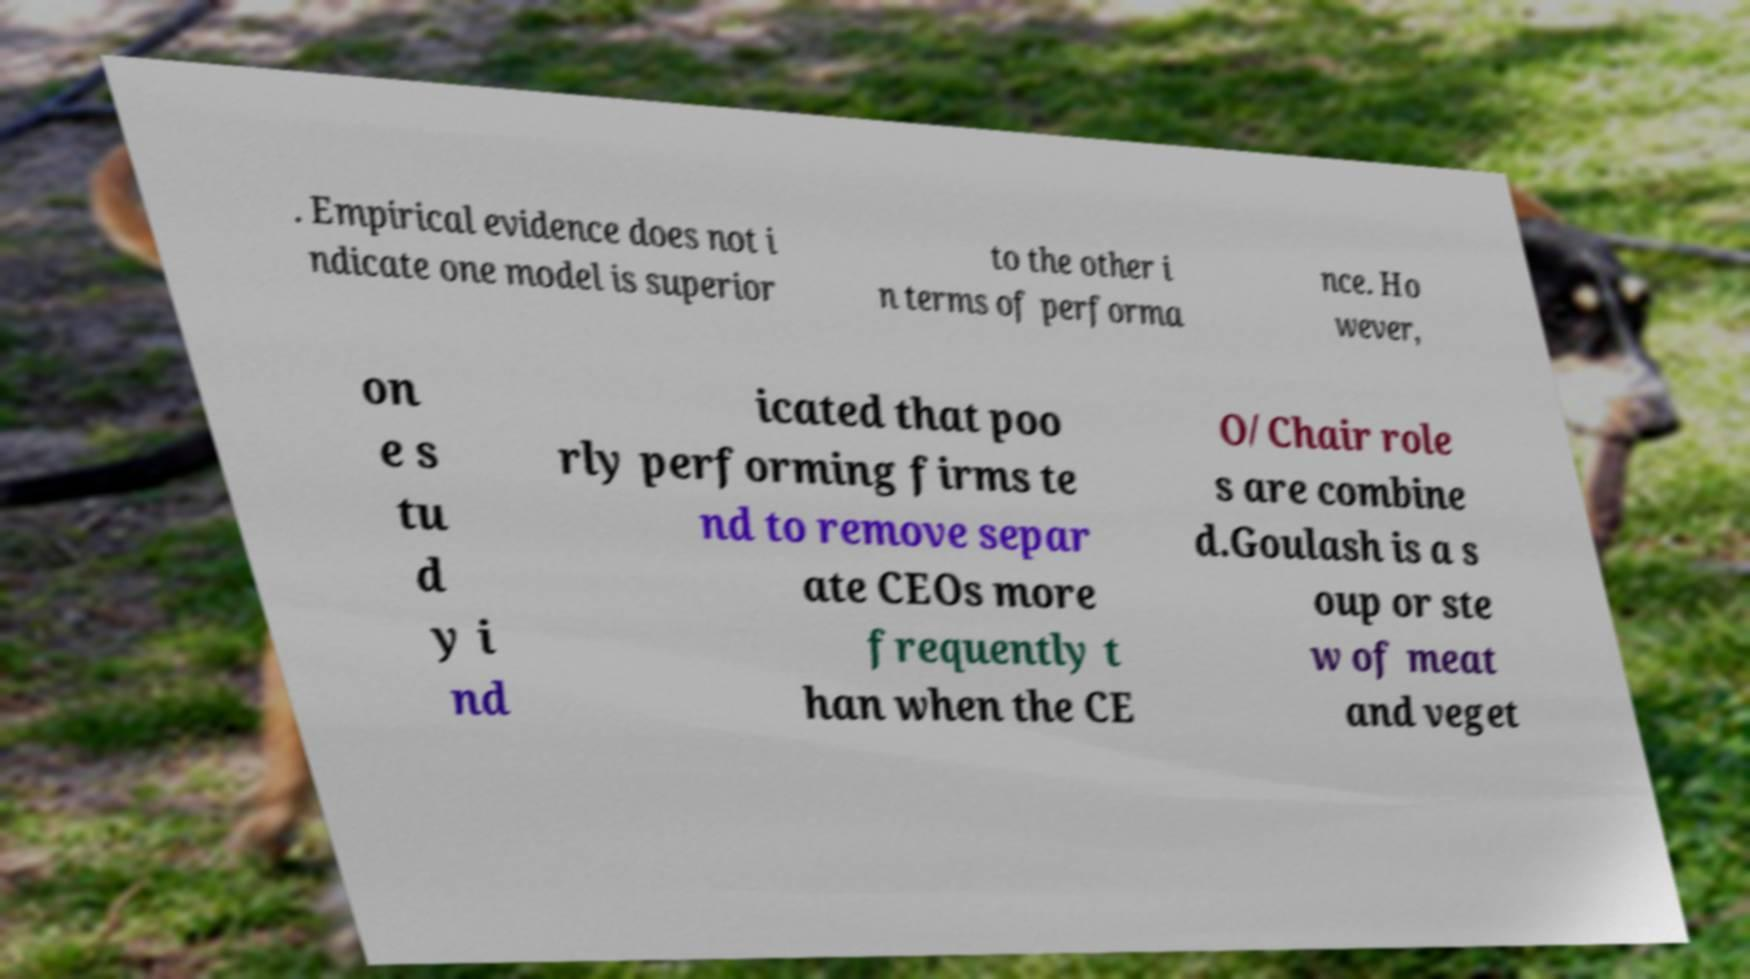Please identify and transcribe the text found in this image. . Empirical evidence does not i ndicate one model is superior to the other i n terms of performa nce. Ho wever, on e s tu d y i nd icated that poo rly performing firms te nd to remove separ ate CEOs more frequently t han when the CE O/Chair role s are combine d.Goulash is a s oup or ste w of meat and veget 